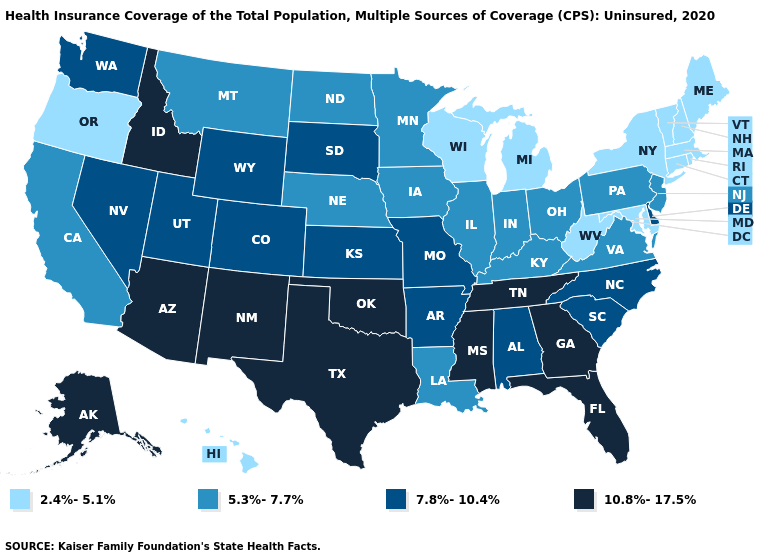How many symbols are there in the legend?
Quick response, please. 4. Does South Carolina have the highest value in the South?
Quick response, please. No. Does New Jersey have a higher value than Michigan?
Keep it brief. Yes. Does Hawaii have the lowest value in the West?
Be succinct. Yes. Does Oklahoma have the highest value in the USA?
Keep it brief. Yes. What is the highest value in the MidWest ?
Keep it brief. 7.8%-10.4%. Does Oregon have the highest value in the USA?
Write a very short answer. No. Does Wyoming have the same value as Utah?
Write a very short answer. Yes. Does the first symbol in the legend represent the smallest category?
Short answer required. Yes. Does Maine have the highest value in the Northeast?
Be succinct. No. Which states have the lowest value in the USA?
Be succinct. Connecticut, Hawaii, Maine, Maryland, Massachusetts, Michigan, New Hampshire, New York, Oregon, Rhode Island, Vermont, West Virginia, Wisconsin. Which states have the lowest value in the West?
Write a very short answer. Hawaii, Oregon. Name the states that have a value in the range 10.8%-17.5%?
Answer briefly. Alaska, Arizona, Florida, Georgia, Idaho, Mississippi, New Mexico, Oklahoma, Tennessee, Texas. What is the value of Washington?
Give a very brief answer. 7.8%-10.4%. Name the states that have a value in the range 5.3%-7.7%?
Keep it brief. California, Illinois, Indiana, Iowa, Kentucky, Louisiana, Minnesota, Montana, Nebraska, New Jersey, North Dakota, Ohio, Pennsylvania, Virginia. 